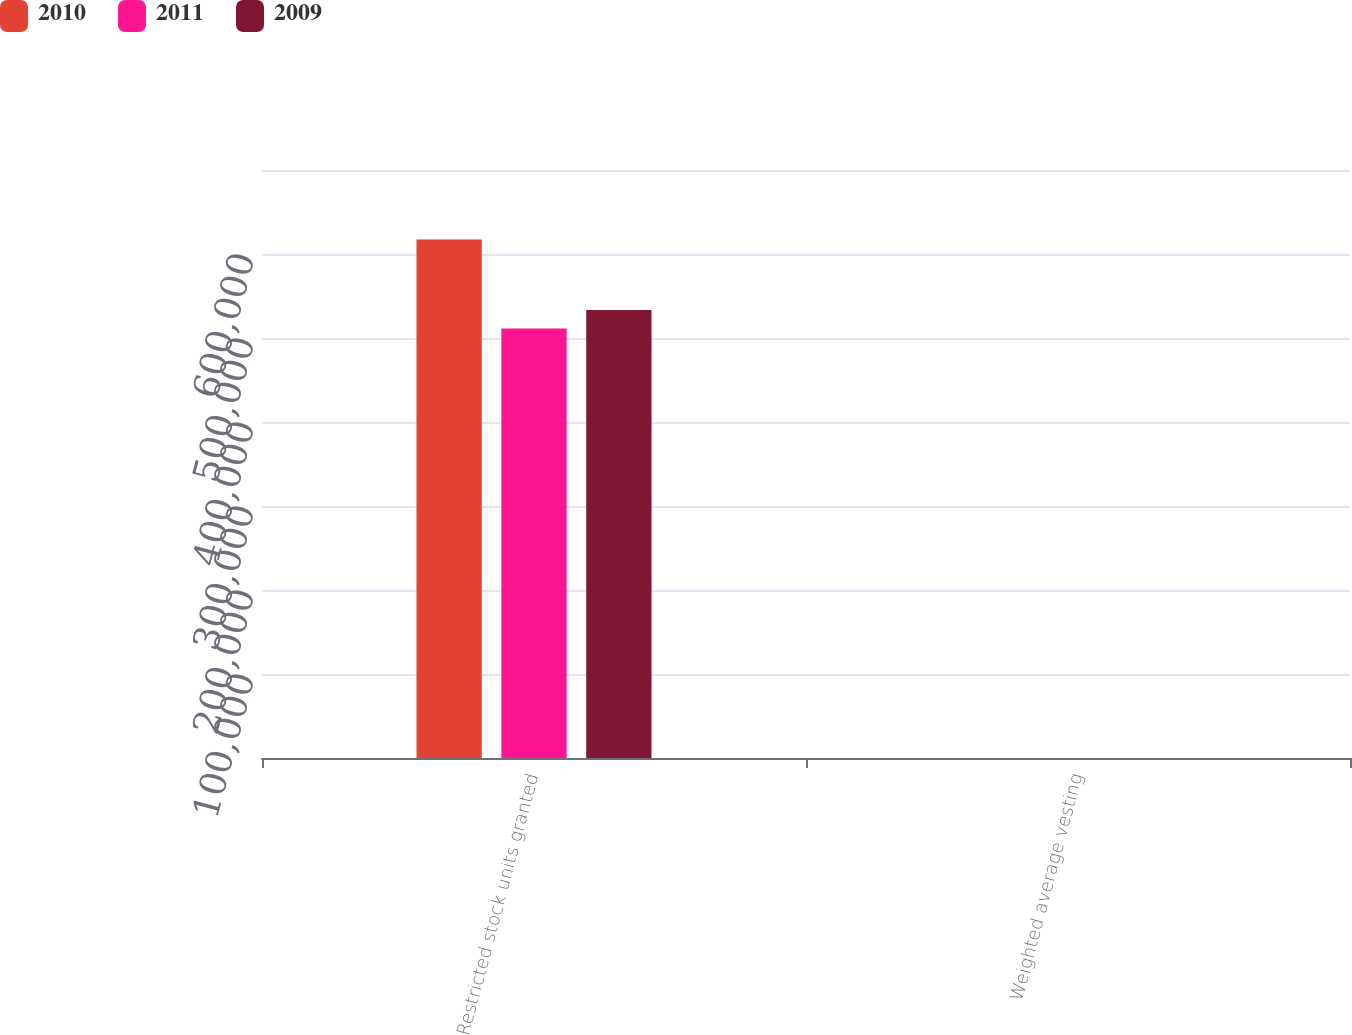Convert chart. <chart><loc_0><loc_0><loc_500><loc_500><stacked_bar_chart><ecel><fcel>Restricted stock units granted<fcel>Weighted average vesting<nl><fcel>2010<fcel>617195<fcel>3<nl><fcel>2011<fcel>511418<fcel>3<nl><fcel>2009<fcel>533399<fcel>3<nl></chart> 